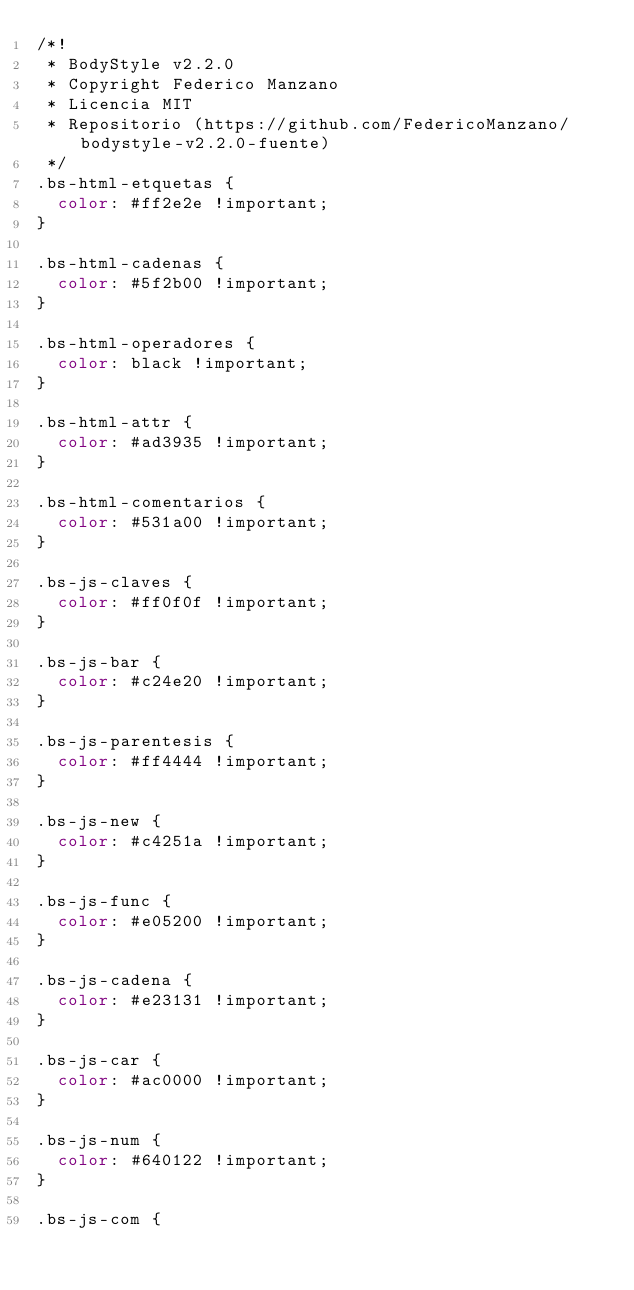Convert code to text. <code><loc_0><loc_0><loc_500><loc_500><_CSS_>/*!
 * BodyStyle v2.2.0
 * Copyright Federico Manzano
 * Licencia MIT
 * Repositorio (https://github.com/FedericoManzano/bodystyle-v2.2.0-fuente)
 */
.bs-html-etquetas {
  color: #ff2e2e !important;
}

.bs-html-cadenas {
  color: #5f2b00 !important;
}

.bs-html-operadores {
  color: black !important;
}

.bs-html-attr {
  color: #ad3935 !important;
}

.bs-html-comentarios {
  color: #531a00 !important;
}

.bs-js-claves {
  color: #ff0f0f !important;
}

.bs-js-bar {
  color: #c24e20 !important;
}

.bs-js-parentesis {
  color: #ff4444 !important;
}

.bs-js-new {
  color: #c4251a !important;
}

.bs-js-func {
  color: #e05200 !important;
}

.bs-js-cadena {
  color: #e23131 !important;
}

.bs-js-car {
  color: #ac0000 !important;
}

.bs-js-num {
  color: #640122 !important;
}

.bs-js-com {</code> 